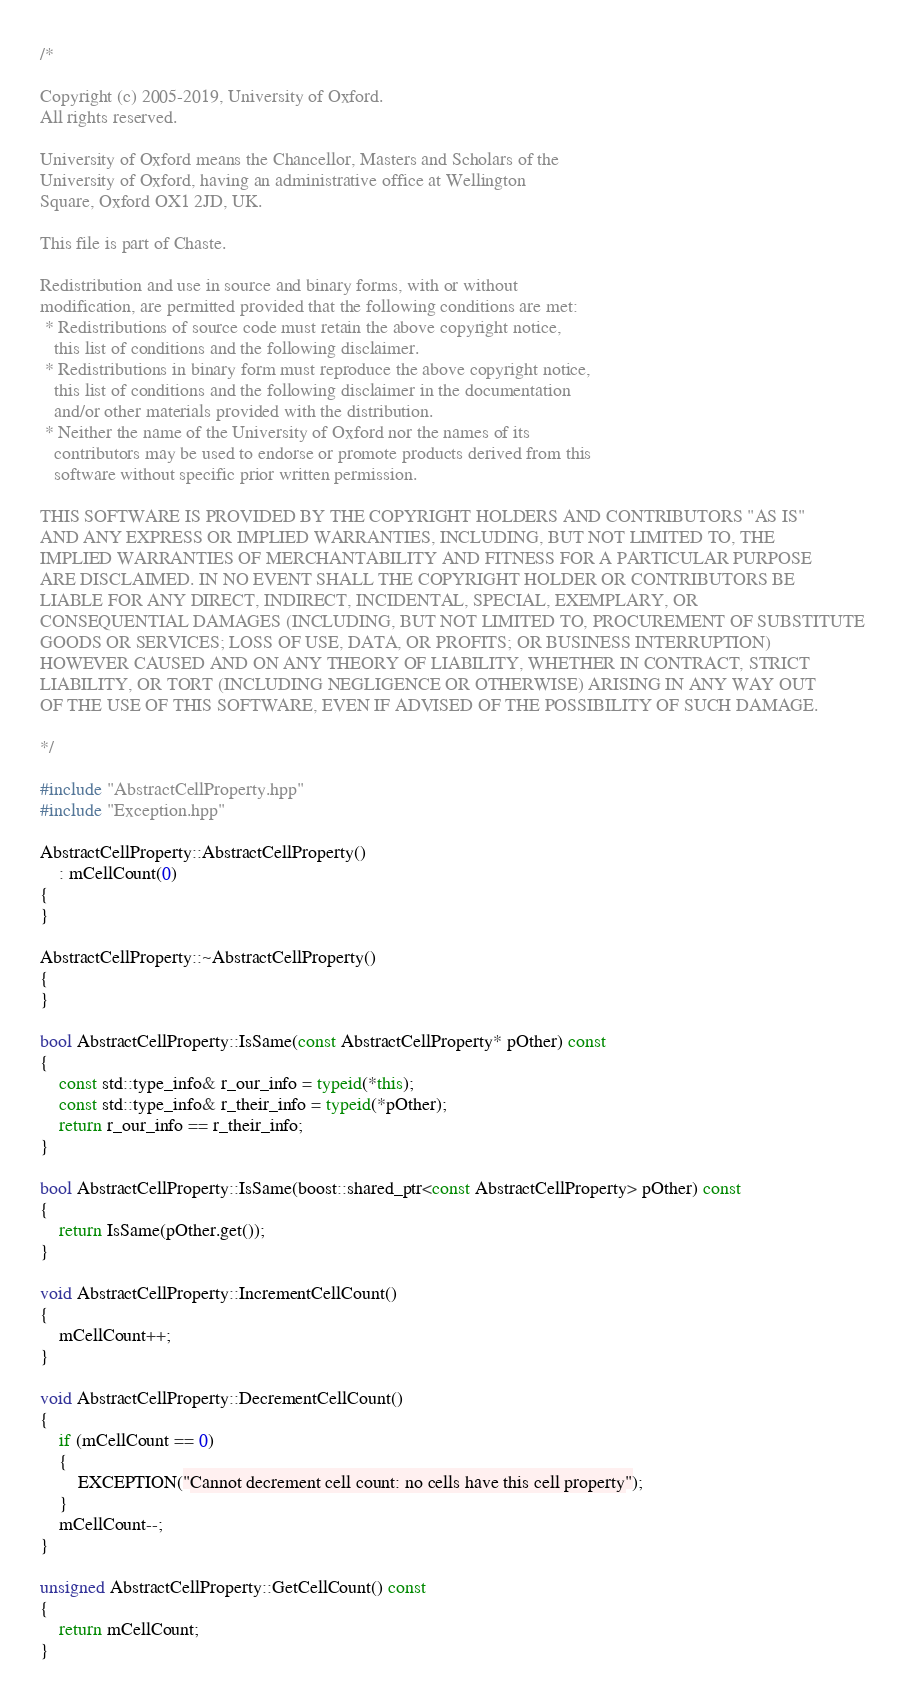Convert code to text. <code><loc_0><loc_0><loc_500><loc_500><_C++_>/*

Copyright (c) 2005-2019, University of Oxford.
All rights reserved.

University of Oxford means the Chancellor, Masters and Scholars of the
University of Oxford, having an administrative office at Wellington
Square, Oxford OX1 2JD, UK.

This file is part of Chaste.

Redistribution and use in source and binary forms, with or without
modification, are permitted provided that the following conditions are met:
 * Redistributions of source code must retain the above copyright notice,
   this list of conditions and the following disclaimer.
 * Redistributions in binary form must reproduce the above copyright notice,
   this list of conditions and the following disclaimer in the documentation
   and/or other materials provided with the distribution.
 * Neither the name of the University of Oxford nor the names of its
   contributors may be used to endorse or promote products derived from this
   software without specific prior written permission.

THIS SOFTWARE IS PROVIDED BY THE COPYRIGHT HOLDERS AND CONTRIBUTORS "AS IS"
AND ANY EXPRESS OR IMPLIED WARRANTIES, INCLUDING, BUT NOT LIMITED TO, THE
IMPLIED WARRANTIES OF MERCHANTABILITY AND FITNESS FOR A PARTICULAR PURPOSE
ARE DISCLAIMED. IN NO EVENT SHALL THE COPYRIGHT HOLDER OR CONTRIBUTORS BE
LIABLE FOR ANY DIRECT, INDIRECT, INCIDENTAL, SPECIAL, EXEMPLARY, OR
CONSEQUENTIAL DAMAGES (INCLUDING, BUT NOT LIMITED TO, PROCUREMENT OF SUBSTITUTE
GOODS OR SERVICES; LOSS OF USE, DATA, OR PROFITS; OR BUSINESS INTERRUPTION)
HOWEVER CAUSED AND ON ANY THEORY OF LIABILITY, WHETHER IN CONTRACT, STRICT
LIABILITY, OR TORT (INCLUDING NEGLIGENCE OR OTHERWISE) ARISING IN ANY WAY OUT
OF THE USE OF THIS SOFTWARE, EVEN IF ADVISED OF THE POSSIBILITY OF SUCH DAMAGE.

*/

#include "AbstractCellProperty.hpp"
#include "Exception.hpp"

AbstractCellProperty::AbstractCellProperty()
    : mCellCount(0)
{
}

AbstractCellProperty::~AbstractCellProperty()
{
}

bool AbstractCellProperty::IsSame(const AbstractCellProperty* pOther) const
{
    const std::type_info& r_our_info = typeid(*this);
    const std::type_info& r_their_info = typeid(*pOther);
    return r_our_info == r_their_info;
}

bool AbstractCellProperty::IsSame(boost::shared_ptr<const AbstractCellProperty> pOther) const
{
    return IsSame(pOther.get());
}

void AbstractCellProperty::IncrementCellCount()
{
    mCellCount++;
}

void AbstractCellProperty::DecrementCellCount()
{
    if (mCellCount == 0)
    {
        EXCEPTION("Cannot decrement cell count: no cells have this cell property");
    }
    mCellCount--;
}

unsigned AbstractCellProperty::GetCellCount() const
{
    return mCellCount;
}

</code> 